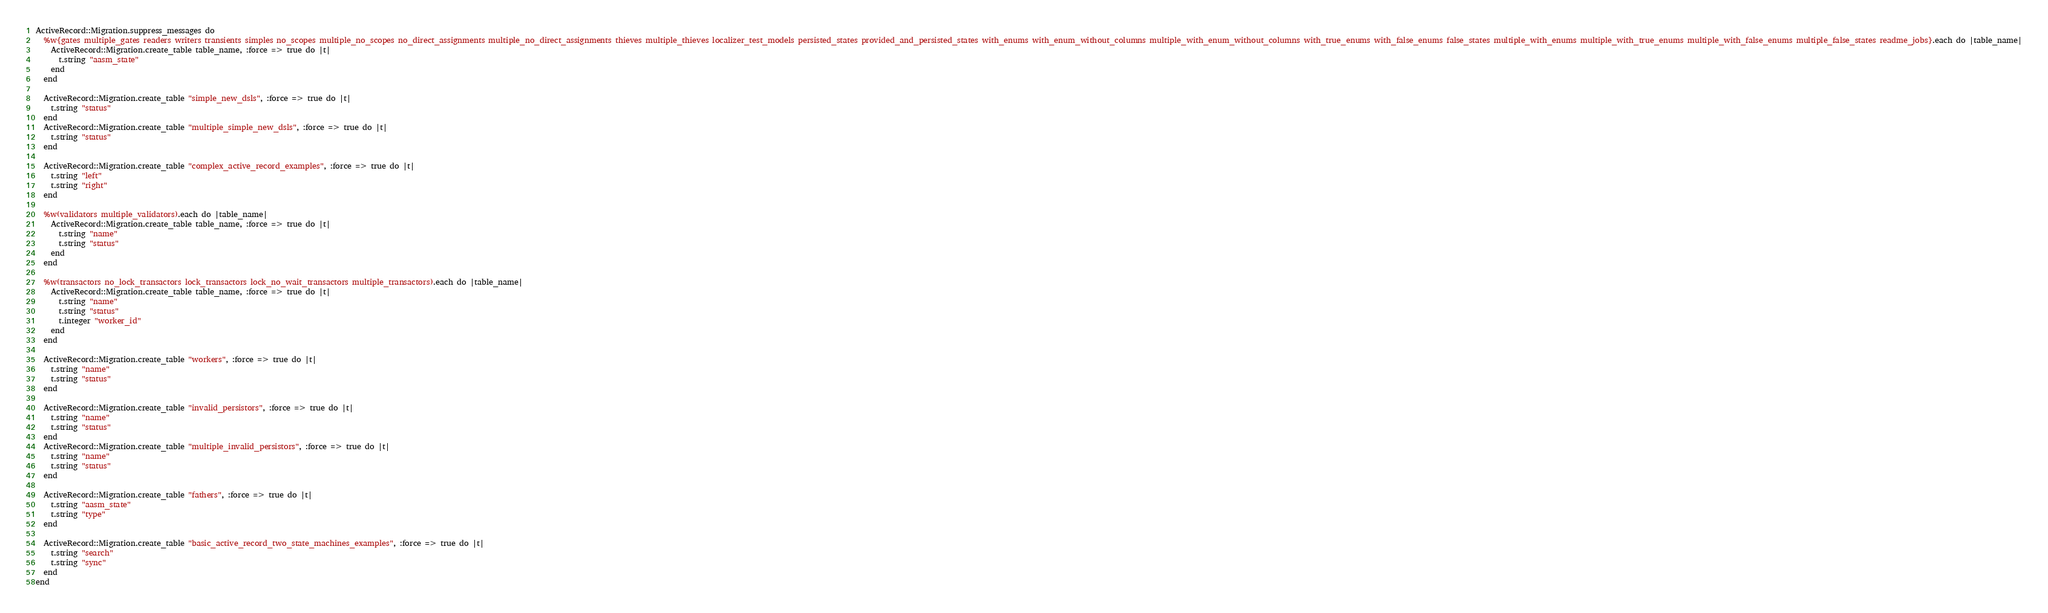<code> <loc_0><loc_0><loc_500><loc_500><_Ruby_>ActiveRecord::Migration.suppress_messages do
  %w{gates multiple_gates readers writers transients simples no_scopes multiple_no_scopes no_direct_assignments multiple_no_direct_assignments thieves multiple_thieves localizer_test_models persisted_states provided_and_persisted_states with_enums with_enum_without_columns multiple_with_enum_without_columns with_true_enums with_false_enums false_states multiple_with_enums multiple_with_true_enums multiple_with_false_enums multiple_false_states readme_jobs}.each do |table_name|
    ActiveRecord::Migration.create_table table_name, :force => true do |t|
      t.string "aasm_state"
    end
  end

  ActiveRecord::Migration.create_table "simple_new_dsls", :force => true do |t|
    t.string "status"
  end
  ActiveRecord::Migration.create_table "multiple_simple_new_dsls", :force => true do |t|
    t.string "status"
  end

  ActiveRecord::Migration.create_table "complex_active_record_examples", :force => true do |t|
    t.string "left"
    t.string "right"
  end

  %w(validators multiple_validators).each do |table_name|
    ActiveRecord::Migration.create_table table_name, :force => true do |t|
      t.string "name"
      t.string "status"
    end
  end

  %w(transactors no_lock_transactors lock_transactors lock_no_wait_transactors multiple_transactors).each do |table_name|
    ActiveRecord::Migration.create_table table_name, :force => true do |t|
      t.string "name"
      t.string "status"
      t.integer "worker_id"
    end
  end

  ActiveRecord::Migration.create_table "workers", :force => true do |t|
    t.string "name"
    t.string "status"
  end

  ActiveRecord::Migration.create_table "invalid_persistors", :force => true do |t|
    t.string "name"
    t.string "status"
  end
  ActiveRecord::Migration.create_table "multiple_invalid_persistors", :force => true do |t|
    t.string "name"
    t.string "status"
  end

  ActiveRecord::Migration.create_table "fathers", :force => true do |t|
    t.string "aasm_state"
    t.string "type"
  end

  ActiveRecord::Migration.create_table "basic_active_record_two_state_machines_examples", :force => true do |t|
    t.string "search"
    t.string "sync"
  end
end
</code> 